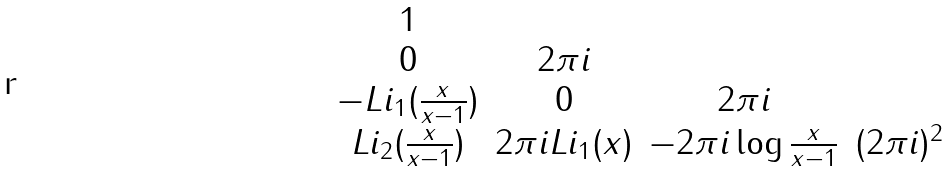<formula> <loc_0><loc_0><loc_500><loc_500>\begin{matrix} 1 & \ & \ & \ \\ 0 & 2 \pi i & \ & \ \\ - L i _ { 1 } ( \frac { x } { x - 1 } ) & 0 & 2 \pi i & \ \\ L i _ { 2 } ( \frac { x } { x - 1 } ) & 2 \pi i L i _ { 1 } ( x ) & - 2 \pi i \log \frac { x } { x - 1 } & ( 2 \pi i ) ^ { 2 } \end{matrix}</formula> 